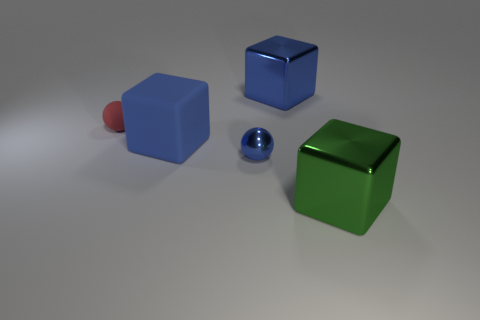Subtract all green blocks. How many blocks are left? 2 Subtract all brown cylinders. How many blue blocks are left? 2 Subtract all gray blocks. Subtract all yellow cylinders. How many blocks are left? 3 Subtract all cubes. How many objects are left? 2 Add 5 big brown metal cylinders. How many objects exist? 10 Subtract 1 blue spheres. How many objects are left? 4 Subtract all small blue metallic things. Subtract all shiny blocks. How many objects are left? 2 Add 2 large green things. How many large green things are left? 3 Add 4 tiny red rubber objects. How many tiny red rubber objects exist? 5 